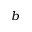Convert formula to latex. <formula><loc_0><loc_0><loc_500><loc_500>^ { b }</formula> 